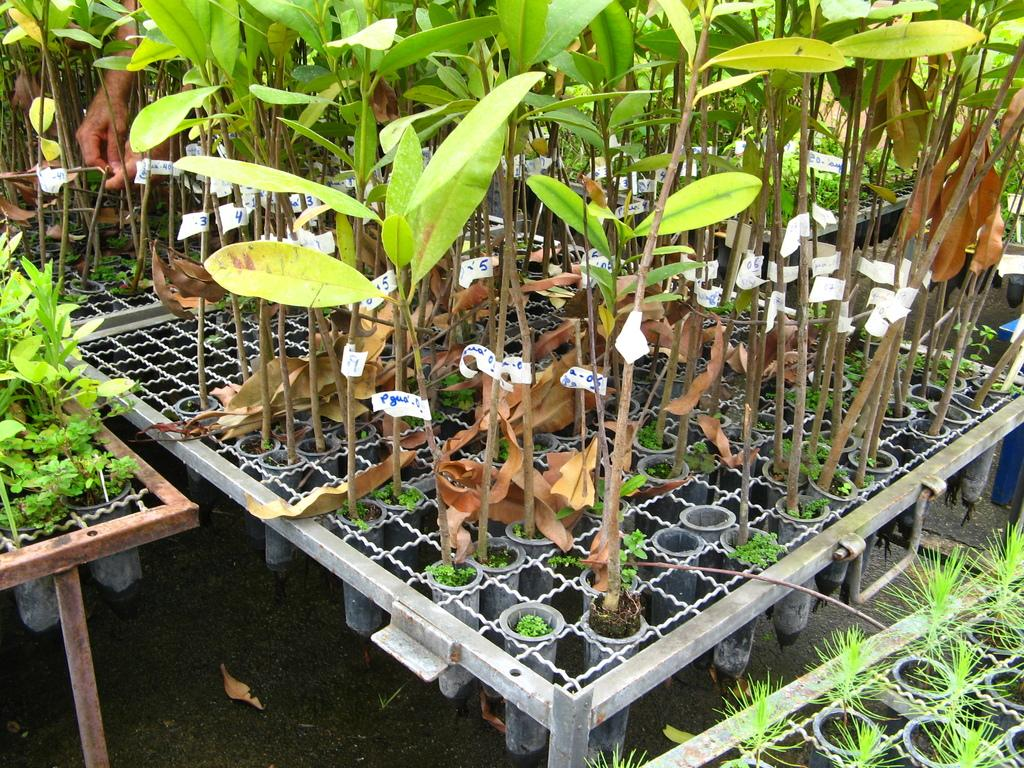What is on the table in the image? There are different kinds of plants on a table in the image. Where is the table located? The table is present on the ground. What can be seen on the left side of the image? There are a person's hands visible on the left side of the image. What type of pear is being cut by the scissors in the image? There are no scissors or pear present in the image. How many matches are visible on the table in the image? There are no matches visible on the table in the image. 